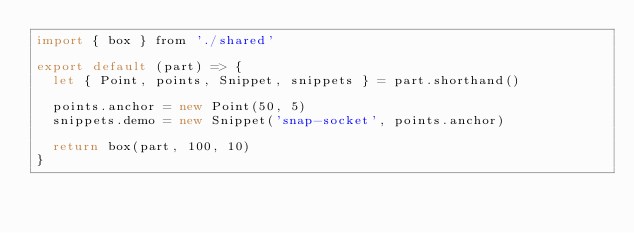<code> <loc_0><loc_0><loc_500><loc_500><_JavaScript_>import { box } from './shared'

export default (part) => {
  let { Point, points, Snippet, snippets } = part.shorthand()

  points.anchor = new Point(50, 5)
  snippets.demo = new Snippet('snap-socket', points.anchor)

  return box(part, 100, 10)
}
</code> 